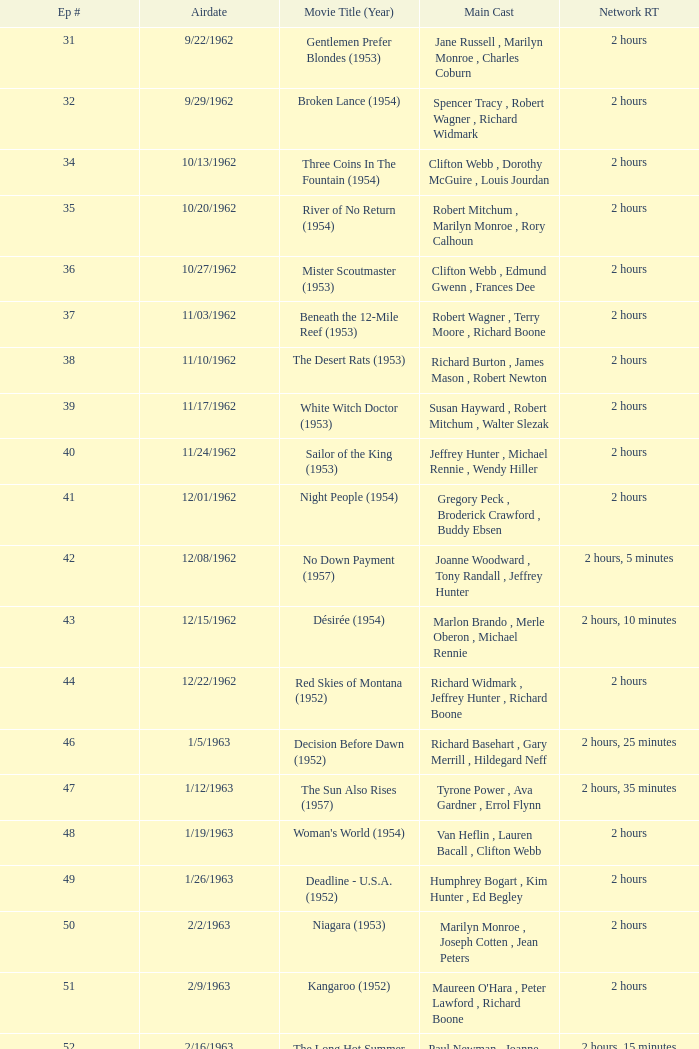How many runtimes does episode 53 have? 1.0. Help me parse the entirety of this table. {'header': ['Ep #', 'Airdate', 'Movie Title (Year)', 'Main Cast', 'Network RT'], 'rows': [['31', '9/22/1962', 'Gentlemen Prefer Blondes (1953)', 'Jane Russell , Marilyn Monroe , Charles Coburn', '2 hours'], ['32', '9/29/1962', 'Broken Lance (1954)', 'Spencer Tracy , Robert Wagner , Richard Widmark', '2 hours'], ['34', '10/13/1962', 'Three Coins In The Fountain (1954)', 'Clifton Webb , Dorothy McGuire , Louis Jourdan', '2 hours'], ['35', '10/20/1962', 'River of No Return (1954)', 'Robert Mitchum , Marilyn Monroe , Rory Calhoun', '2 hours'], ['36', '10/27/1962', 'Mister Scoutmaster (1953)', 'Clifton Webb , Edmund Gwenn , Frances Dee', '2 hours'], ['37', '11/03/1962', 'Beneath the 12-Mile Reef (1953)', 'Robert Wagner , Terry Moore , Richard Boone', '2 hours'], ['38', '11/10/1962', 'The Desert Rats (1953)', 'Richard Burton , James Mason , Robert Newton', '2 hours'], ['39', '11/17/1962', 'White Witch Doctor (1953)', 'Susan Hayward , Robert Mitchum , Walter Slezak', '2 hours'], ['40', '11/24/1962', 'Sailor of the King (1953)', 'Jeffrey Hunter , Michael Rennie , Wendy Hiller', '2 hours'], ['41', '12/01/1962', 'Night People (1954)', 'Gregory Peck , Broderick Crawford , Buddy Ebsen', '2 hours'], ['42', '12/08/1962', 'No Down Payment (1957)', 'Joanne Woodward , Tony Randall , Jeffrey Hunter', '2 hours, 5 minutes'], ['43', '12/15/1962', 'Désirée (1954)', 'Marlon Brando , Merle Oberon , Michael Rennie', '2 hours, 10 minutes'], ['44', '12/22/1962', 'Red Skies of Montana (1952)', 'Richard Widmark , Jeffrey Hunter , Richard Boone', '2 hours'], ['46', '1/5/1963', 'Decision Before Dawn (1952)', 'Richard Basehart , Gary Merrill , Hildegard Neff', '2 hours, 25 minutes'], ['47', '1/12/1963', 'The Sun Also Rises (1957)', 'Tyrone Power , Ava Gardner , Errol Flynn', '2 hours, 35 minutes'], ['48', '1/19/1963', "Woman's World (1954)", 'Van Heflin , Lauren Bacall , Clifton Webb', '2 hours'], ['49', '1/26/1963', 'Deadline - U.S.A. (1952)', 'Humphrey Bogart , Kim Hunter , Ed Begley', '2 hours'], ['50', '2/2/1963', 'Niagara (1953)', 'Marilyn Monroe , Joseph Cotten , Jean Peters', '2 hours'], ['51', '2/9/1963', 'Kangaroo (1952)', "Maureen O'Hara , Peter Lawford , Richard Boone", '2 hours'], ['52', '2/16/1963', 'The Long Hot Summer (1958)', 'Paul Newman , Joanne Woodward , Orson Wells', '2 hours, 15 minutes'], ['53', '2/23/1963', "The President's Lady (1953)", 'Susan Hayward , Charlton Heston , John McIntire', '2 hours'], ['54', '3/2/1963', 'The Roots of Heaven (1958)', 'Errol Flynn , Juliette Greco , Eddie Albert', '2 hours, 25 minutes'], ['55', '3/9/1963', 'In Love and War (1958)', 'Robert Wagner , Hope Lange , Jeffrey Hunter', '2 hours, 10 minutes'], ['56', '3/16/1963', 'A Certain Smile (1958)', 'Rossano Brazzi , Joan Fontaine , Johnny Mathis', '2 hours, 5 minutes'], ['57', '3/23/1963', 'Fraulein (1958)', 'Dana Wynter , Mel Ferrer , Theodore Bikel', '2 hours'], ['59', '4/6/1963', 'Night and the City (1950)', 'Richard Widmark , Gene Tierney , Herbert Lom', '2 hours']]} 